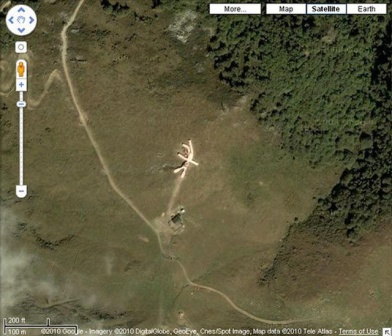Analyze the image in a comprehensive and detailed manner. The image captures an aerial perspective of a forest opening, prominently featuring a large, white X-shaped structure with a metallic sheen that starkly contrasts with the lush greenery surrounding it. This enigmatic structure stands at the center of a clearing and is closely accompanied by a smaller metallic structure. A dirt road meanders close to these structures, adding a rustic and somewhat isolated charm to the scene. This is clearly a screenshot from Google Maps, complete with navigational controls and a scale, which offer context and proportion to the scene displayed. The juxtaposition of the vast forest and the peculiar man-made constructions spur curiosity, suggesting a possible landing pad, art installation, or an emergency signal. The scene as a whole is intriguing and raises numerous questions about the purpose and history of these structures. 